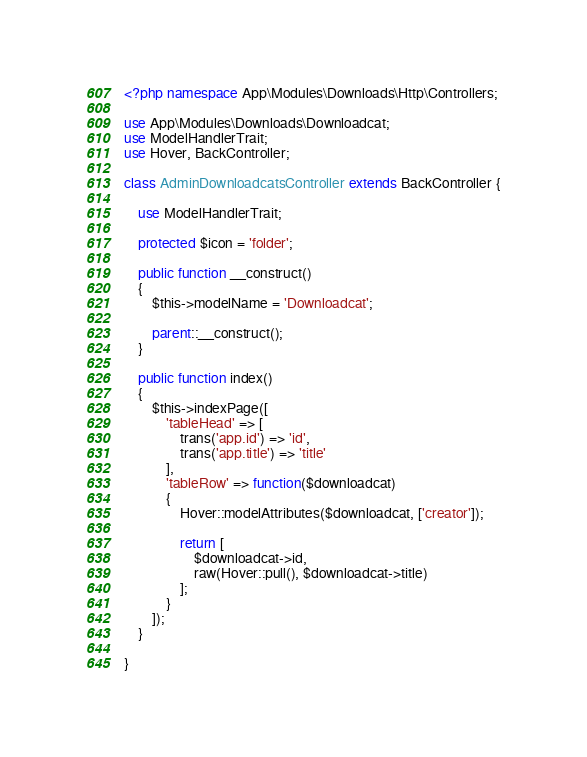<code> <loc_0><loc_0><loc_500><loc_500><_PHP_><?php namespace App\Modules\Downloads\Http\Controllers;

use App\Modules\Downloads\Downloadcat;
use ModelHandlerTrait;
use Hover, BackController;

class AdminDownloadcatsController extends BackController {

    use ModelHandlerTrait;

    protected $icon = 'folder';

    public function __construct()
    {
        $this->modelName = 'Downloadcat';

        parent::__construct();
    }

    public function index()
    {
        $this->indexPage([
            'tableHead' => [
                trans('app.id') => 'id', 
                trans('app.title') => 'title'
            ],
            'tableRow' => function($downloadcat)
            {
                Hover::modelAttributes($downloadcat, ['creator']);

                return [
                    $downloadcat->id,
                    raw(Hover::pull(), $downloadcat->title)
                ];
            }
        ]);
    }

}</code> 